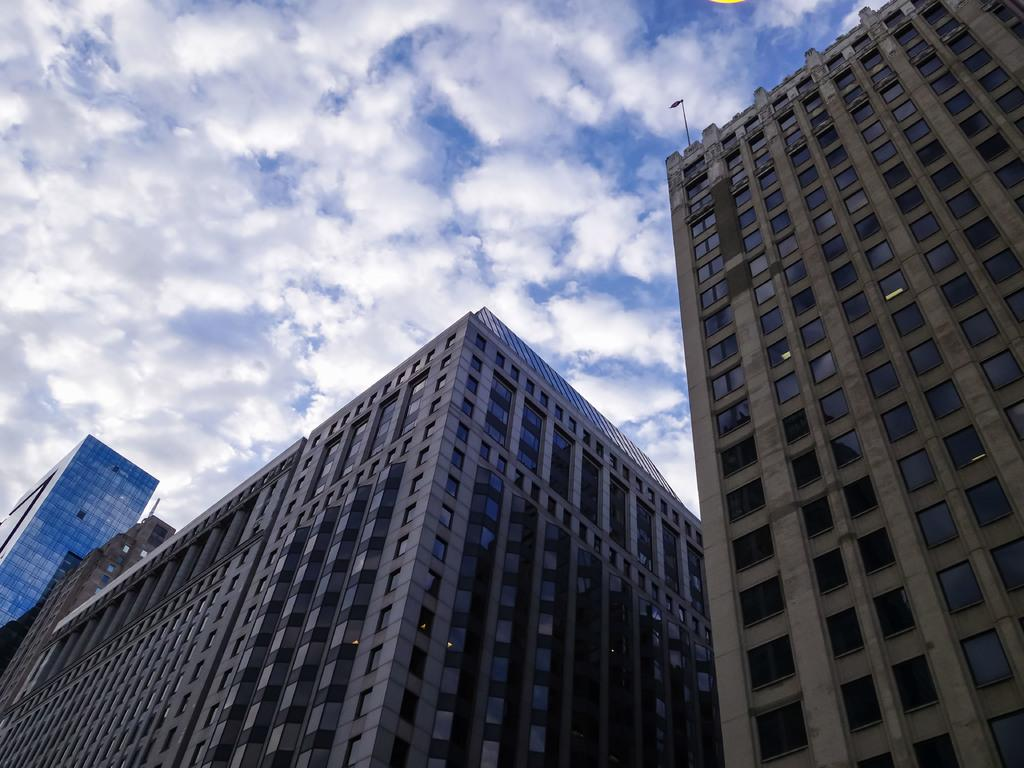What type of structures are located in the foreground of the image? There are buildings in the foreground of the image. What can be seen in the middle of the image? There is a building and a flag in the middle of the image. What is visible at the top of the image? The sky is visible at the top of the image. What type of dinner is being served in the image? There is no dinner present in the image; it features buildings, a flag, and the sky. How many horses are visible in the image? There are no horses present in the image. 